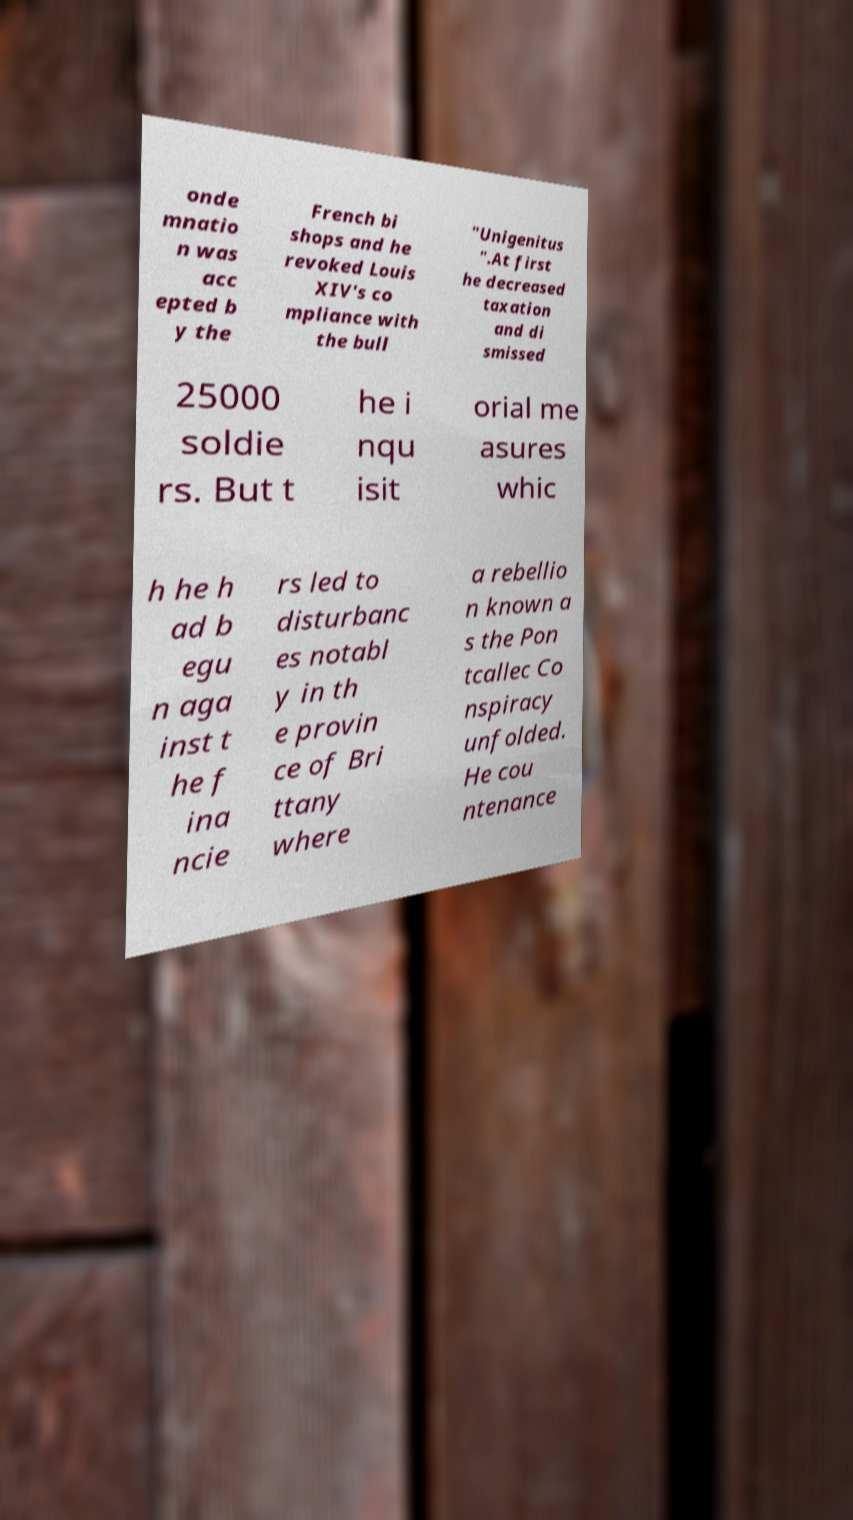Could you assist in decoding the text presented in this image and type it out clearly? onde mnatio n was acc epted b y the French bi shops and he revoked Louis XIV's co mpliance with the bull "Unigenitus ".At first he decreased taxation and di smissed 25000 soldie rs. But t he i nqu isit orial me asures whic h he h ad b egu n aga inst t he f ina ncie rs led to disturbanc es notabl y in th e provin ce of Bri ttany where a rebellio n known a s the Pon tcallec Co nspiracy unfolded. He cou ntenance 